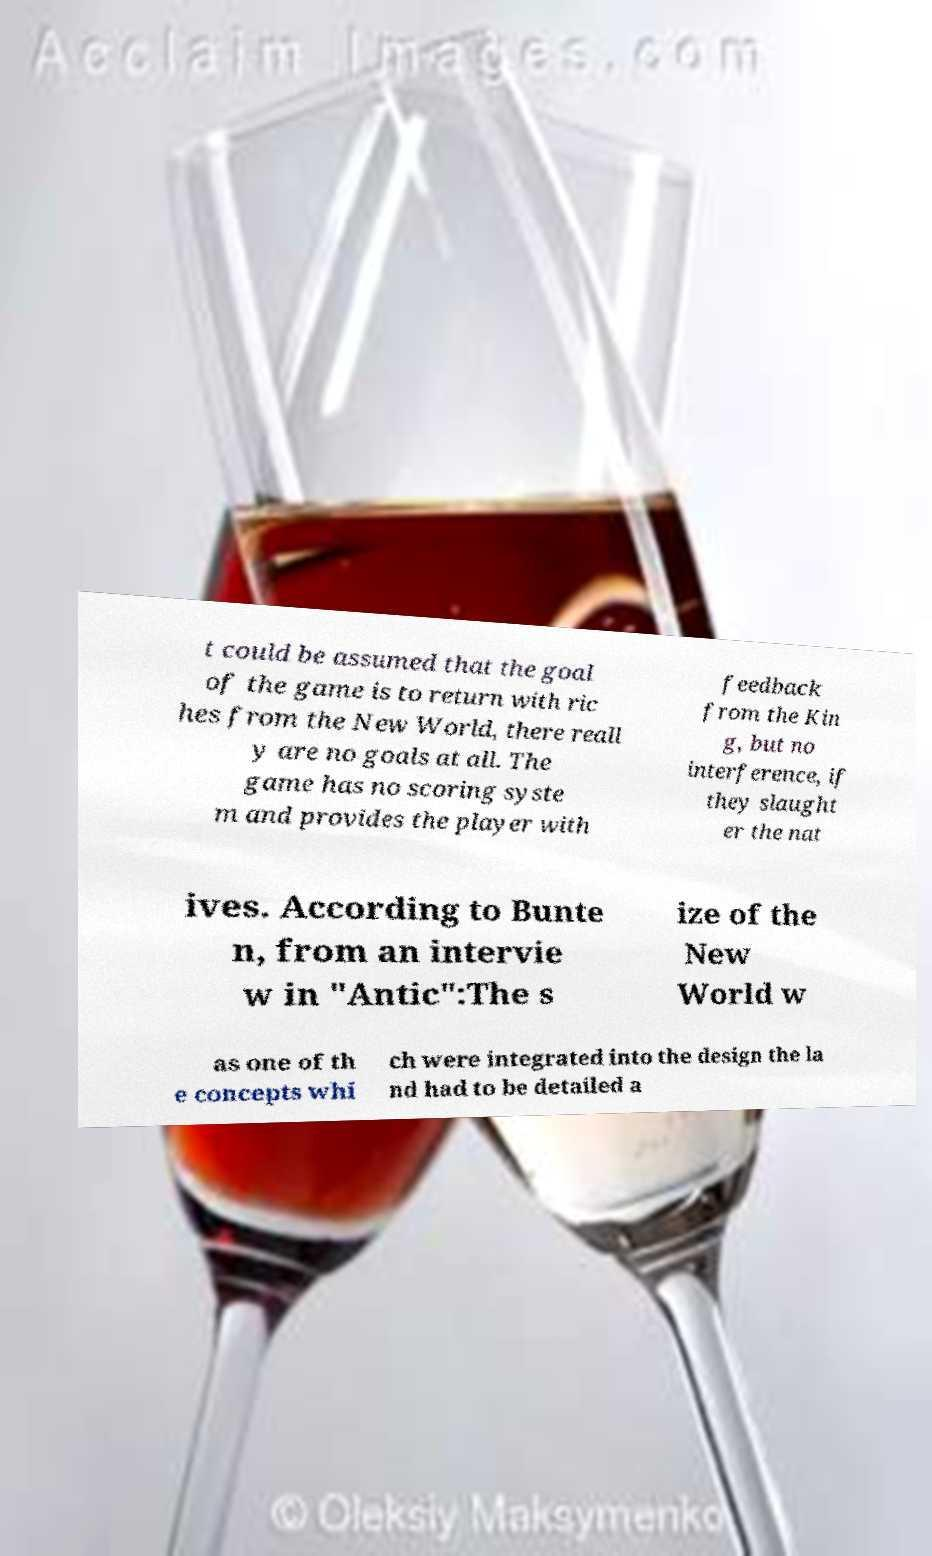Could you assist in decoding the text presented in this image and type it out clearly? t could be assumed that the goal of the game is to return with ric hes from the New World, there reall y are no goals at all. The game has no scoring syste m and provides the player with feedback from the Kin g, but no interference, if they slaught er the nat ives. According to Bunte n, from an intervie w in "Antic":The s ize of the New World w as one of th e concepts whi ch were integrated into the design the la nd had to be detailed a 